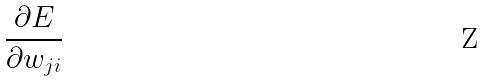Convert formula to latex. <formula><loc_0><loc_0><loc_500><loc_500>\frac { \partial E } { \partial w _ { j i } }</formula> 